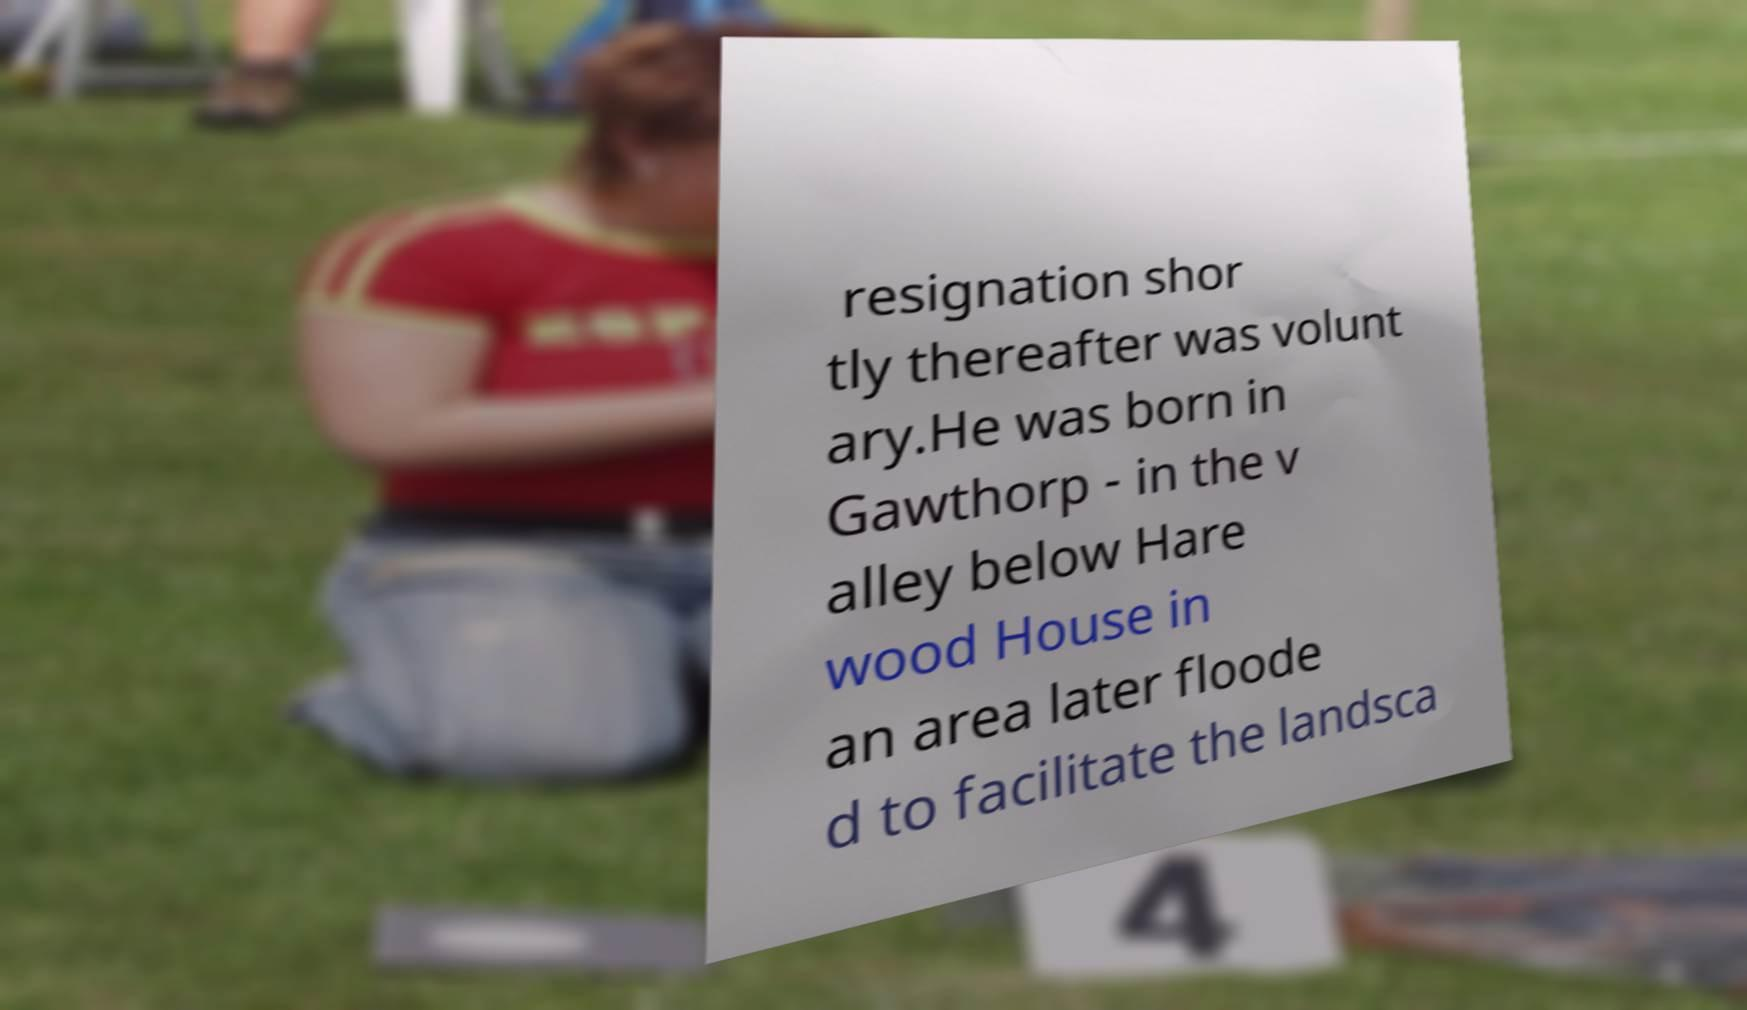Please read and relay the text visible in this image. What does it say? resignation shor tly thereafter was volunt ary.He was born in Gawthorp - in the v alley below Hare wood House in an area later floode d to facilitate the landsca 